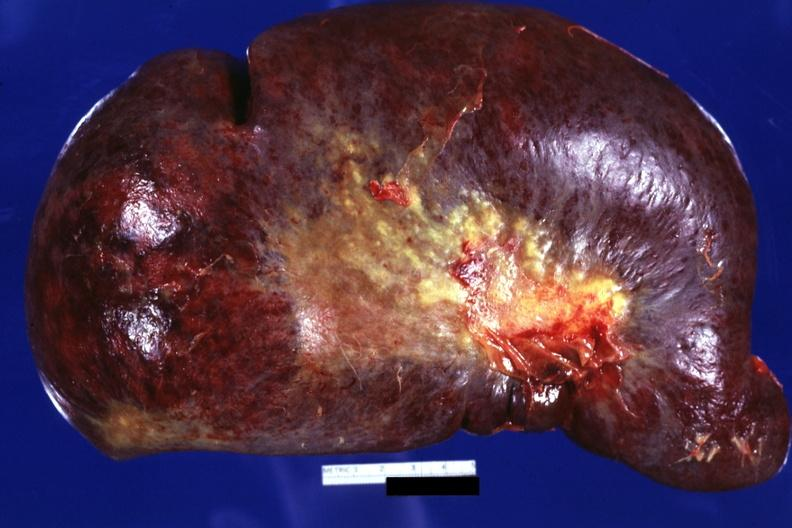what does this image show?
Answer the question using a single word or phrase. External view huge spleen 